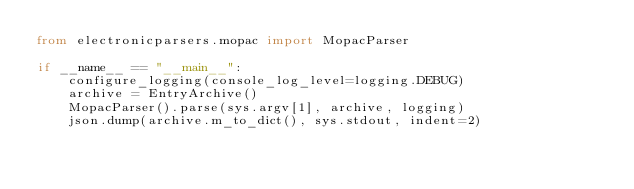<code> <loc_0><loc_0><loc_500><loc_500><_Python_>from electronicparsers.mopac import MopacParser

if __name__ == "__main__":
    configure_logging(console_log_level=logging.DEBUG)
    archive = EntryArchive()
    MopacParser().parse(sys.argv[1], archive, logging)
    json.dump(archive.m_to_dict(), sys.stdout, indent=2)
</code> 